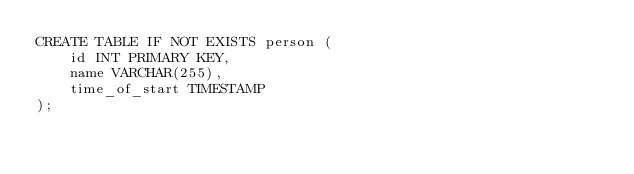<code> <loc_0><loc_0><loc_500><loc_500><_SQL_>CREATE TABLE IF NOT EXISTS person (
    id INT PRIMARY KEY,
    name VARCHAR(255),
    time_of_start TIMESTAMP
);</code> 